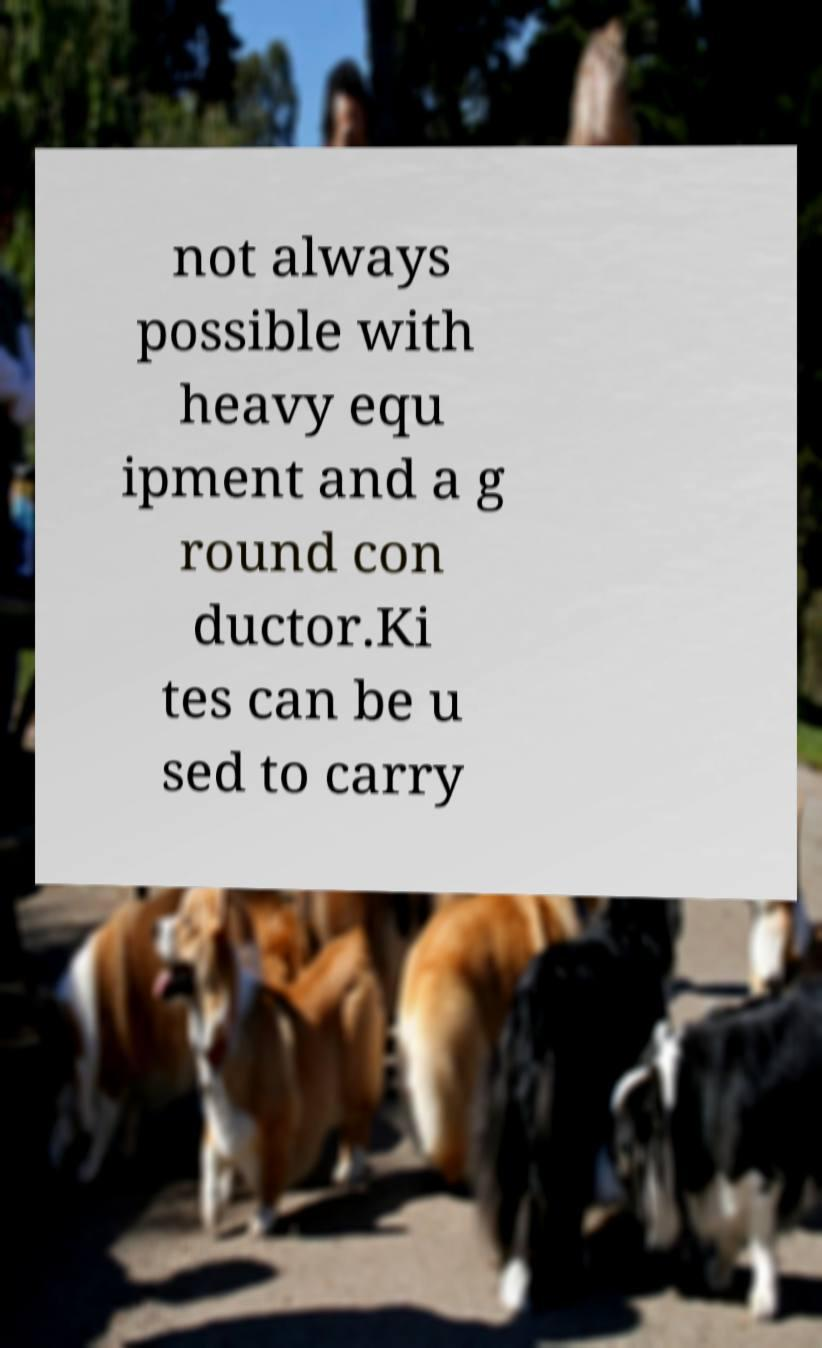There's text embedded in this image that I need extracted. Can you transcribe it verbatim? not always possible with heavy equ ipment and a g round con ductor.Ki tes can be u sed to carry 